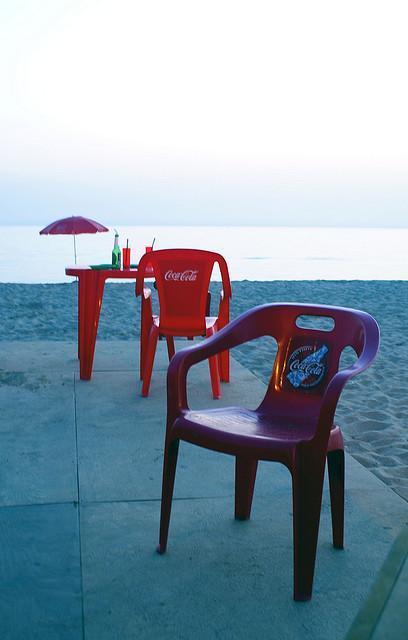How many chairs are there?
Give a very brief answer. 2. How many dining tables can you see?
Give a very brief answer. 1. How many people are sitting?
Give a very brief answer. 0. 